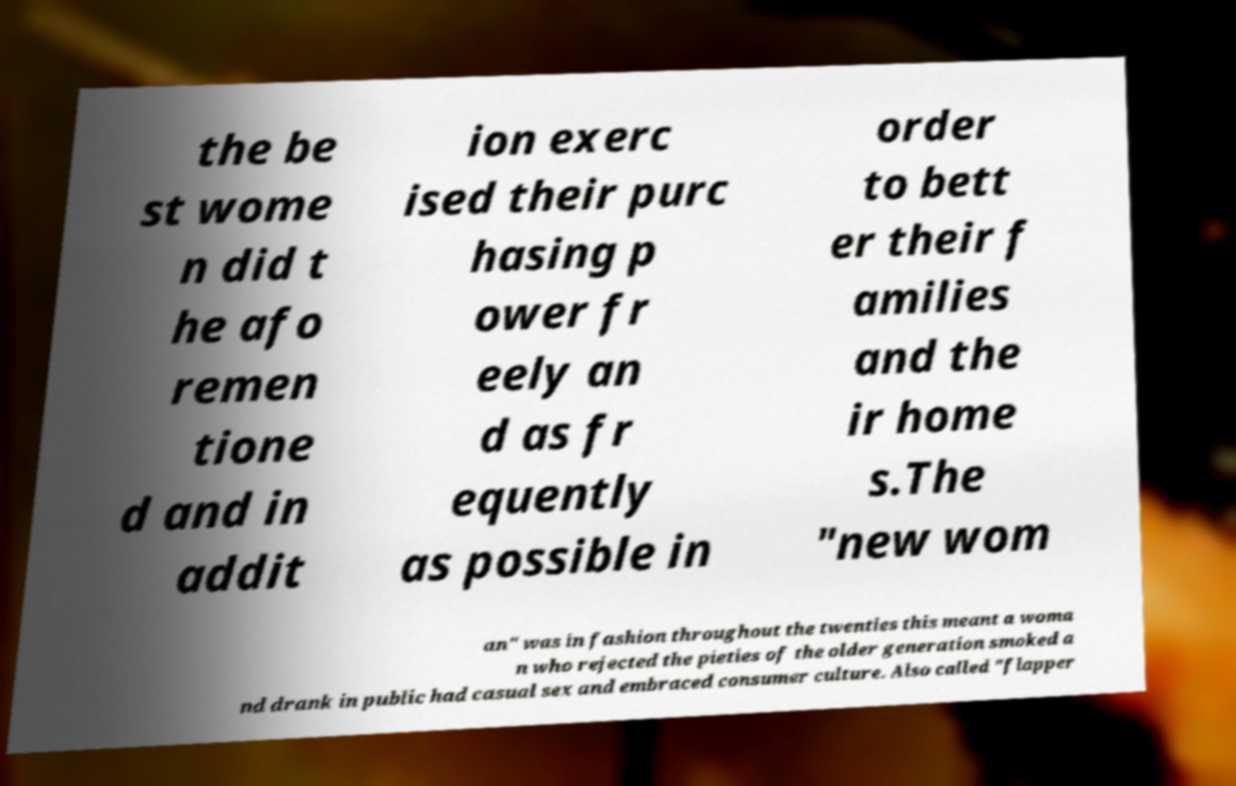Could you assist in decoding the text presented in this image and type it out clearly? the be st wome n did t he afo remen tione d and in addit ion exerc ised their purc hasing p ower fr eely an d as fr equently as possible in order to bett er their f amilies and the ir home s.The "new wom an" was in fashion throughout the twenties this meant a woma n who rejected the pieties of the older generation smoked a nd drank in public had casual sex and embraced consumer culture. Also called "flapper 